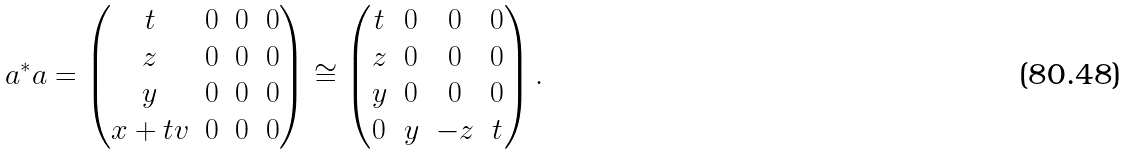<formula> <loc_0><loc_0><loc_500><loc_500>a ^ { * } a = \begin{pmatrix} t & 0 & 0 & 0 \\ z & 0 & 0 & 0 \\ y & 0 & 0 & 0 \\ x + t v & 0 & 0 & 0 \end{pmatrix} \cong \begin{pmatrix} t & 0 & 0 & 0 \\ z & 0 & 0 & 0 \\ y & 0 & 0 & 0 \\ 0 & y & - z & t \end{pmatrix} .</formula> 